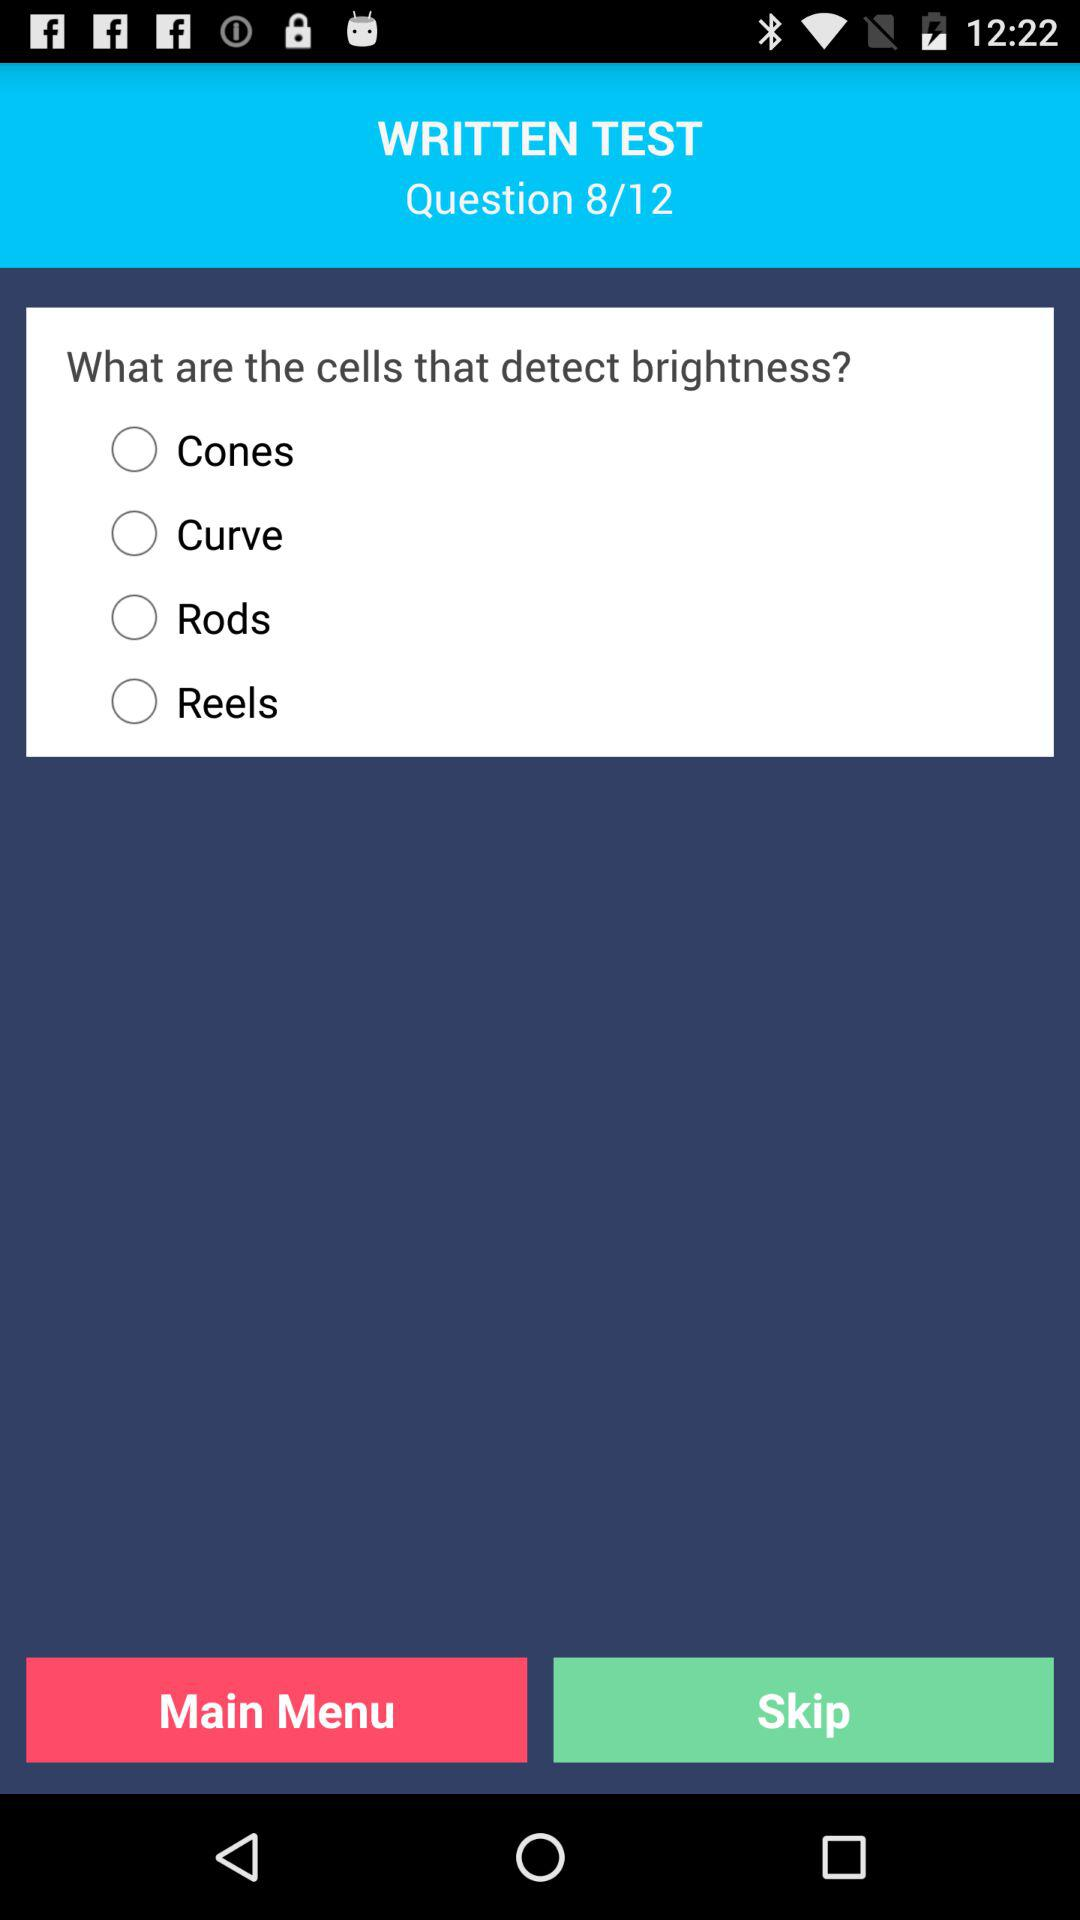What is the number of the current question shown on the screen? The number of the currently shown question is 8. 